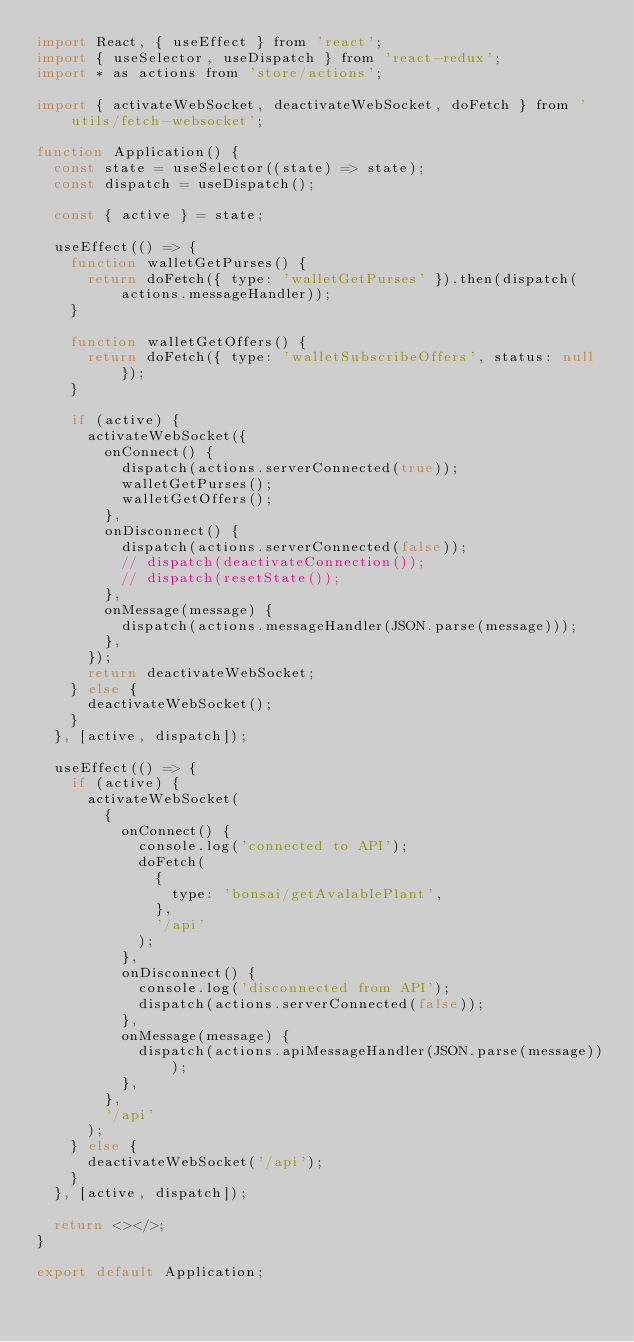Convert code to text. <code><loc_0><loc_0><loc_500><loc_500><_JavaScript_>import React, { useEffect } from 'react';
import { useSelector, useDispatch } from 'react-redux';
import * as actions from 'store/actions';

import { activateWebSocket, deactivateWebSocket, doFetch } from 'utils/fetch-websocket';

function Application() {
  const state = useSelector((state) => state);
  const dispatch = useDispatch();

  const { active } = state;

  useEffect(() => {
    function walletGetPurses() {
      return doFetch({ type: 'walletGetPurses' }).then(dispatch(actions.messageHandler));
    }

    function walletGetOffers() {
      return doFetch({ type: 'walletSubscribeOffers', status: null });
    }

    if (active) {
      activateWebSocket({
        onConnect() {
          dispatch(actions.serverConnected(true));
          walletGetPurses();
          walletGetOffers();
        },
        onDisconnect() {
          dispatch(actions.serverConnected(false));
          // dispatch(deactivateConnection());
          // dispatch(resetState());
        },
        onMessage(message) {
          dispatch(actions.messageHandler(JSON.parse(message)));
        },
      });
      return deactivateWebSocket;
    } else {
      deactivateWebSocket();
    }
  }, [active, dispatch]);

  useEffect(() => {
    if (active) {
      activateWebSocket(
        {
          onConnect() {
            console.log('connected to API');
            doFetch(
              {
                type: 'bonsai/getAvalablePlant',
              },
              '/api'
            );
          },
          onDisconnect() {
            console.log('disconnected from API');
            dispatch(actions.serverConnected(false));
          },
          onMessage(message) {
            dispatch(actions.apiMessageHandler(JSON.parse(message)));
          },
        },
        '/api'
      );
    } else {
      deactivateWebSocket('/api');
    }
  }, [active, dispatch]);

  return <></>;
}

export default Application;
</code> 